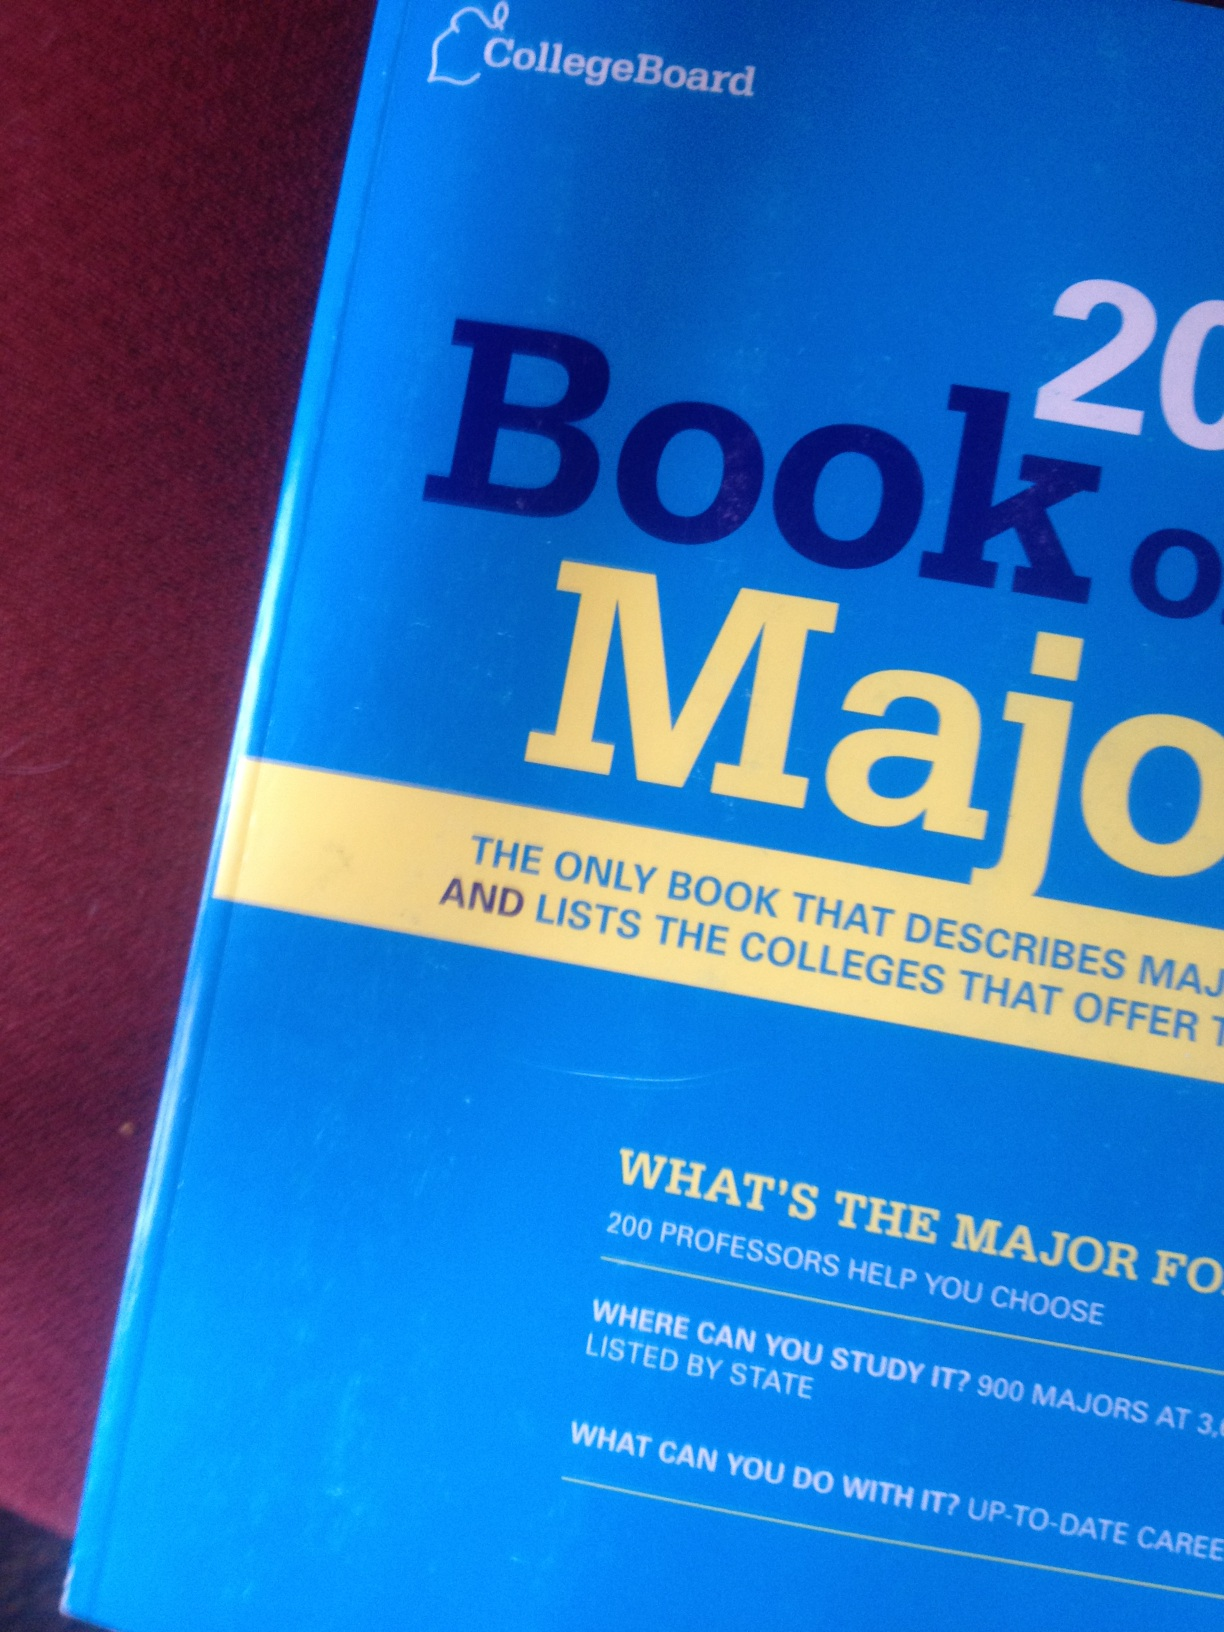What specific insights do the professors provide in this book? Professors in the 'Book of Majors 2014' offer valuable insights based on their expertise and experience. They provide guidance on curriculum expectations, the relevance and application of the major in the real world, research opportunities, and advice on academic success and career preparation. Their contributions help students understand the depth and breadth of each major and the skills needed to excel in their chosen fields. Can you elaborate on the list of colleges featured in the book? The book lists colleges across the United States that offer various majors, organized by state for easy reference. Each college entry may include details about the programs, unique features of the institution, faculty expertise, research facilities, and any special opportunities such as internships, study abroad programs, or industry partnerships. This comprehensive directory helps students locate and compare institutions that best match their academic and career goals. If this book inspired a national competition among colleges, what would the competition entail? If inspired by the 'Book of Majors 2014', a national competition among colleges could focus on innovative academic programs and student achievements. Colleges could compete in categories such as best new curriculum design, most successful alumni in emerging fields, pioneering research projects, excellence in teaching methodologies, and impactful community partnerships. The competition could be judged by panels of educators, industry professionals, and student representatives, and the winners would receive recognition and funding for further academic advancements. 